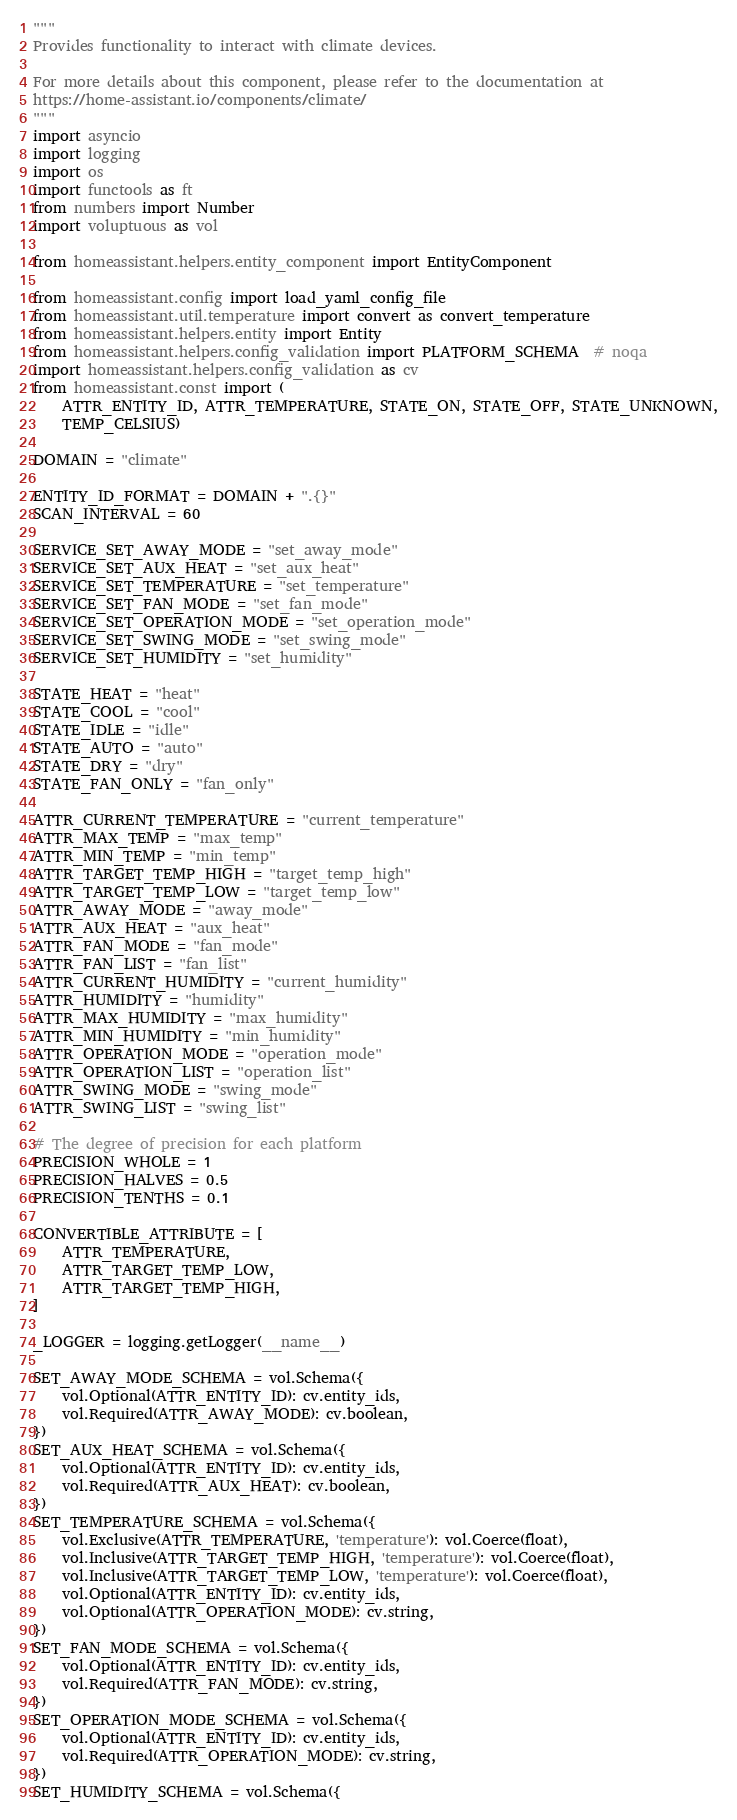<code> <loc_0><loc_0><loc_500><loc_500><_Python_>"""
Provides functionality to interact with climate devices.

For more details about this component, please refer to the documentation at
https://home-assistant.io/components/climate/
"""
import asyncio
import logging
import os
import functools as ft
from numbers import Number
import voluptuous as vol

from homeassistant.helpers.entity_component import EntityComponent

from homeassistant.config import load_yaml_config_file
from homeassistant.util.temperature import convert as convert_temperature
from homeassistant.helpers.entity import Entity
from homeassistant.helpers.config_validation import PLATFORM_SCHEMA  # noqa
import homeassistant.helpers.config_validation as cv
from homeassistant.const import (
    ATTR_ENTITY_ID, ATTR_TEMPERATURE, STATE_ON, STATE_OFF, STATE_UNKNOWN,
    TEMP_CELSIUS)

DOMAIN = "climate"

ENTITY_ID_FORMAT = DOMAIN + ".{}"
SCAN_INTERVAL = 60

SERVICE_SET_AWAY_MODE = "set_away_mode"
SERVICE_SET_AUX_HEAT = "set_aux_heat"
SERVICE_SET_TEMPERATURE = "set_temperature"
SERVICE_SET_FAN_MODE = "set_fan_mode"
SERVICE_SET_OPERATION_MODE = "set_operation_mode"
SERVICE_SET_SWING_MODE = "set_swing_mode"
SERVICE_SET_HUMIDITY = "set_humidity"

STATE_HEAT = "heat"
STATE_COOL = "cool"
STATE_IDLE = "idle"
STATE_AUTO = "auto"
STATE_DRY = "dry"
STATE_FAN_ONLY = "fan_only"

ATTR_CURRENT_TEMPERATURE = "current_temperature"
ATTR_MAX_TEMP = "max_temp"
ATTR_MIN_TEMP = "min_temp"
ATTR_TARGET_TEMP_HIGH = "target_temp_high"
ATTR_TARGET_TEMP_LOW = "target_temp_low"
ATTR_AWAY_MODE = "away_mode"
ATTR_AUX_HEAT = "aux_heat"
ATTR_FAN_MODE = "fan_mode"
ATTR_FAN_LIST = "fan_list"
ATTR_CURRENT_HUMIDITY = "current_humidity"
ATTR_HUMIDITY = "humidity"
ATTR_MAX_HUMIDITY = "max_humidity"
ATTR_MIN_HUMIDITY = "min_humidity"
ATTR_OPERATION_MODE = "operation_mode"
ATTR_OPERATION_LIST = "operation_list"
ATTR_SWING_MODE = "swing_mode"
ATTR_SWING_LIST = "swing_list"

# The degree of precision for each platform
PRECISION_WHOLE = 1
PRECISION_HALVES = 0.5
PRECISION_TENTHS = 0.1

CONVERTIBLE_ATTRIBUTE = [
    ATTR_TEMPERATURE,
    ATTR_TARGET_TEMP_LOW,
    ATTR_TARGET_TEMP_HIGH,
]

_LOGGER = logging.getLogger(__name__)

SET_AWAY_MODE_SCHEMA = vol.Schema({
    vol.Optional(ATTR_ENTITY_ID): cv.entity_ids,
    vol.Required(ATTR_AWAY_MODE): cv.boolean,
})
SET_AUX_HEAT_SCHEMA = vol.Schema({
    vol.Optional(ATTR_ENTITY_ID): cv.entity_ids,
    vol.Required(ATTR_AUX_HEAT): cv.boolean,
})
SET_TEMPERATURE_SCHEMA = vol.Schema({
    vol.Exclusive(ATTR_TEMPERATURE, 'temperature'): vol.Coerce(float),
    vol.Inclusive(ATTR_TARGET_TEMP_HIGH, 'temperature'): vol.Coerce(float),
    vol.Inclusive(ATTR_TARGET_TEMP_LOW, 'temperature'): vol.Coerce(float),
    vol.Optional(ATTR_ENTITY_ID): cv.entity_ids,
    vol.Optional(ATTR_OPERATION_MODE): cv.string,
})
SET_FAN_MODE_SCHEMA = vol.Schema({
    vol.Optional(ATTR_ENTITY_ID): cv.entity_ids,
    vol.Required(ATTR_FAN_MODE): cv.string,
})
SET_OPERATION_MODE_SCHEMA = vol.Schema({
    vol.Optional(ATTR_ENTITY_ID): cv.entity_ids,
    vol.Required(ATTR_OPERATION_MODE): cv.string,
})
SET_HUMIDITY_SCHEMA = vol.Schema({</code> 